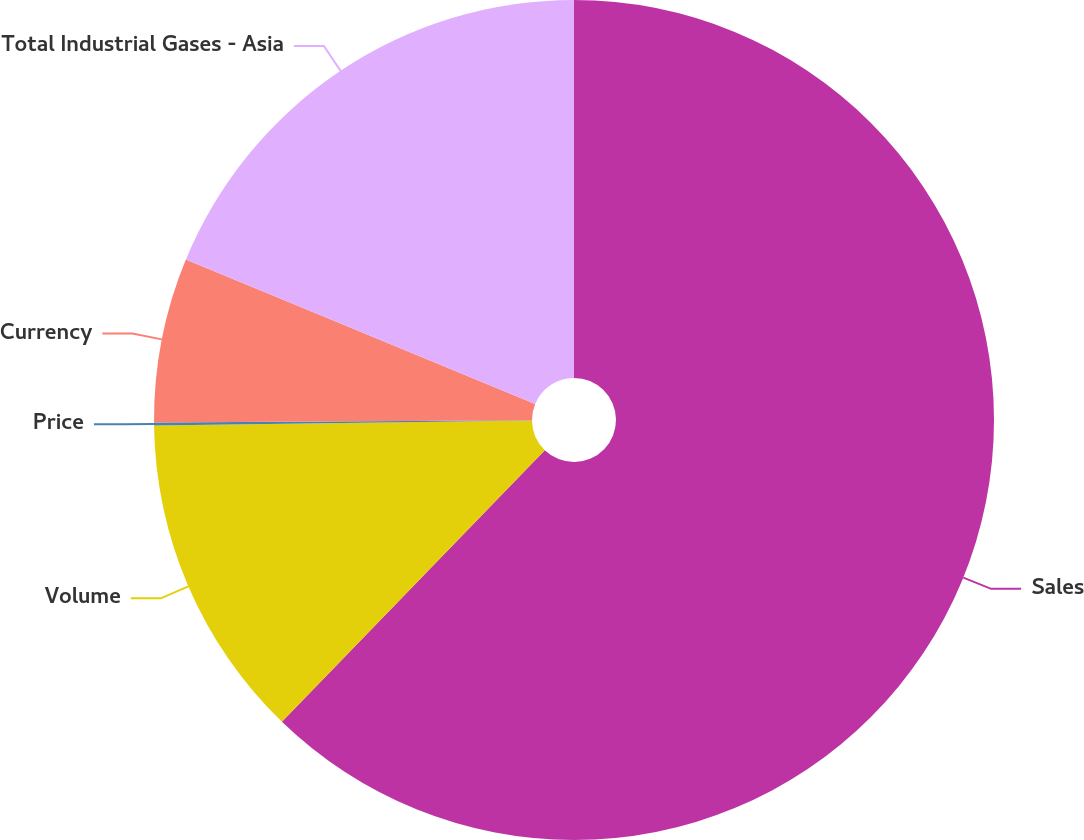Convert chart to OTSL. <chart><loc_0><loc_0><loc_500><loc_500><pie_chart><fcel>Sales<fcel>Volume<fcel>Price<fcel>Currency<fcel>Total Industrial Gases - Asia<nl><fcel>62.24%<fcel>12.55%<fcel>0.12%<fcel>6.33%<fcel>18.76%<nl></chart> 